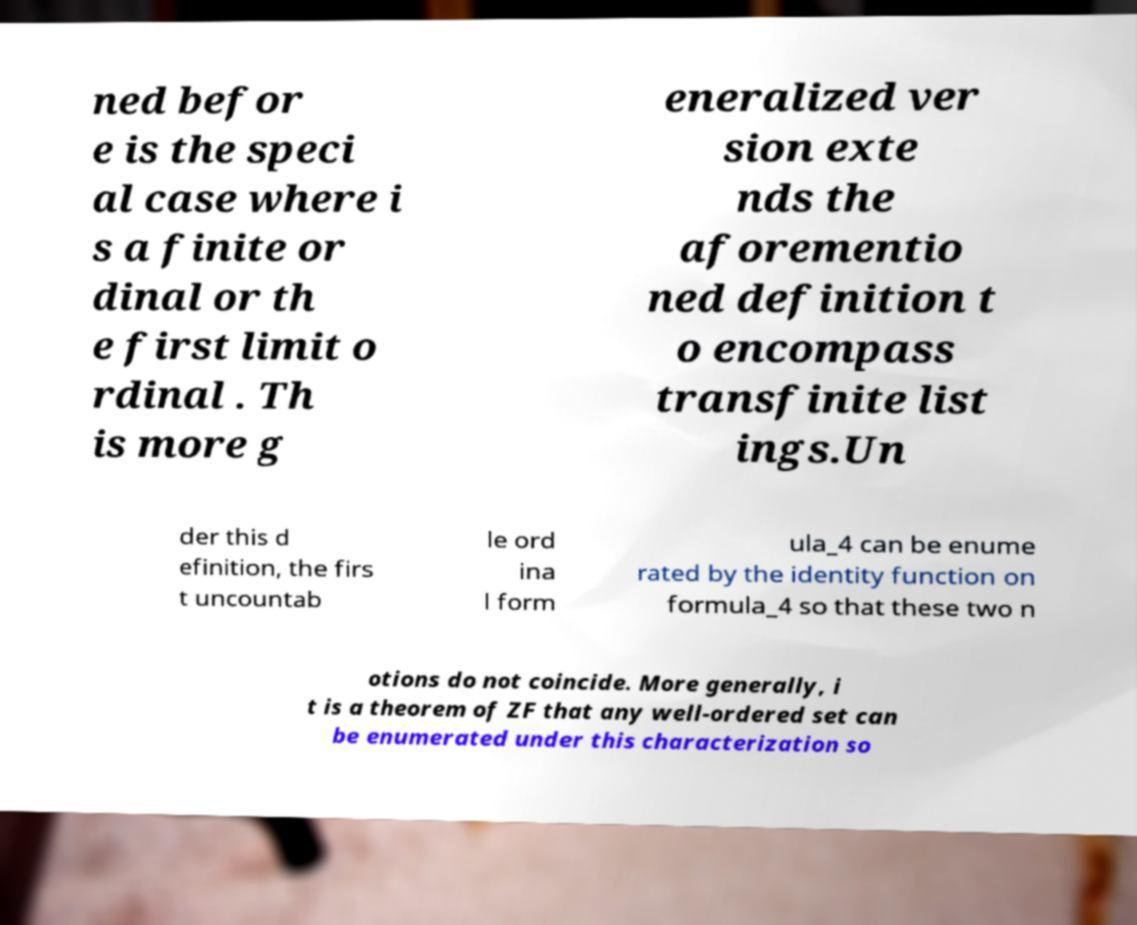Can you accurately transcribe the text from the provided image for me? ned befor e is the speci al case where i s a finite or dinal or th e first limit o rdinal . Th is more g eneralized ver sion exte nds the aforementio ned definition t o encompass transfinite list ings.Un der this d efinition, the firs t uncountab le ord ina l form ula_4 can be enume rated by the identity function on formula_4 so that these two n otions do not coincide. More generally, i t is a theorem of ZF that any well-ordered set can be enumerated under this characterization so 